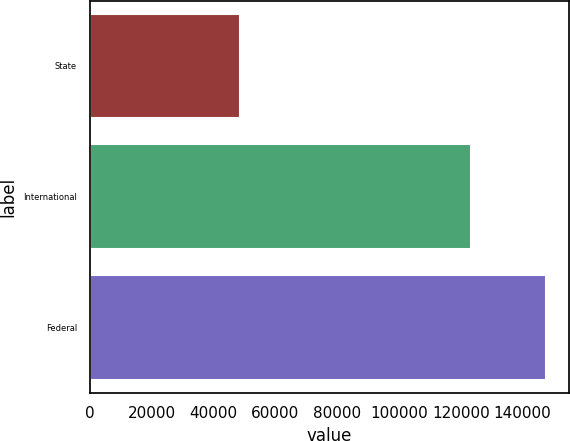<chart> <loc_0><loc_0><loc_500><loc_500><bar_chart><fcel>State<fcel>International<fcel>Federal<nl><fcel>48460<fcel>123297<fcel>147604<nl></chart> 